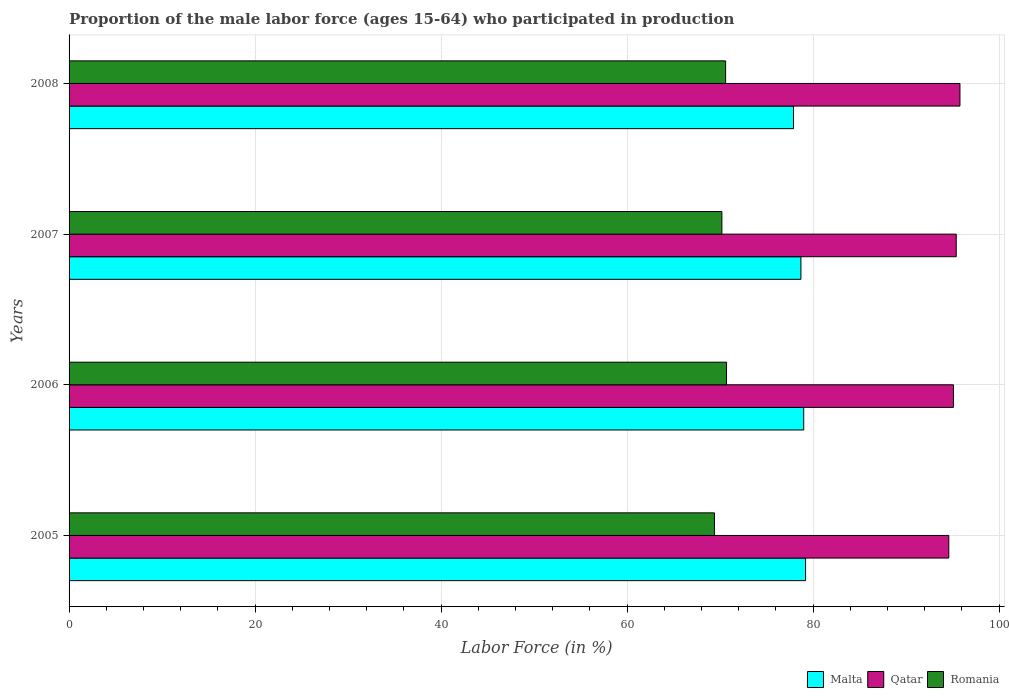How many different coloured bars are there?
Offer a very short reply. 3. What is the proportion of the male labor force who participated in production in Romania in 2006?
Your answer should be compact. 70.7. Across all years, what is the maximum proportion of the male labor force who participated in production in Romania?
Your response must be concise. 70.7. Across all years, what is the minimum proportion of the male labor force who participated in production in Malta?
Give a very brief answer. 77.9. What is the total proportion of the male labor force who participated in production in Malta in the graph?
Your response must be concise. 314.8. What is the difference between the proportion of the male labor force who participated in production in Qatar in 2005 and that in 2006?
Make the answer very short. -0.5. What is the difference between the proportion of the male labor force who participated in production in Malta in 2006 and the proportion of the male labor force who participated in production in Romania in 2005?
Your answer should be compact. 9.6. What is the average proportion of the male labor force who participated in production in Romania per year?
Give a very brief answer. 70.22. In the year 2008, what is the difference between the proportion of the male labor force who participated in production in Romania and proportion of the male labor force who participated in production in Malta?
Ensure brevity in your answer.  -7.3. In how many years, is the proportion of the male labor force who participated in production in Malta greater than 16 %?
Keep it short and to the point. 4. What is the ratio of the proportion of the male labor force who participated in production in Qatar in 2005 to that in 2006?
Give a very brief answer. 0.99. Is the proportion of the male labor force who participated in production in Qatar in 2006 less than that in 2007?
Offer a terse response. Yes. Is the difference between the proportion of the male labor force who participated in production in Romania in 2005 and 2007 greater than the difference between the proportion of the male labor force who participated in production in Malta in 2005 and 2007?
Ensure brevity in your answer.  No. What is the difference between the highest and the second highest proportion of the male labor force who participated in production in Qatar?
Provide a succinct answer. 0.4. What is the difference between the highest and the lowest proportion of the male labor force who participated in production in Qatar?
Offer a very short reply. 1.2. In how many years, is the proportion of the male labor force who participated in production in Romania greater than the average proportion of the male labor force who participated in production in Romania taken over all years?
Keep it short and to the point. 2. What does the 3rd bar from the top in 2005 represents?
Offer a terse response. Malta. What does the 2nd bar from the bottom in 2005 represents?
Give a very brief answer. Qatar. Is it the case that in every year, the sum of the proportion of the male labor force who participated in production in Romania and proportion of the male labor force who participated in production in Qatar is greater than the proportion of the male labor force who participated in production in Malta?
Your response must be concise. Yes. How many bars are there?
Give a very brief answer. 12. Does the graph contain any zero values?
Keep it short and to the point. No. Does the graph contain grids?
Offer a very short reply. Yes. How many legend labels are there?
Your answer should be compact. 3. How are the legend labels stacked?
Keep it short and to the point. Horizontal. What is the title of the graph?
Your answer should be compact. Proportion of the male labor force (ages 15-64) who participated in production. Does "New Caledonia" appear as one of the legend labels in the graph?
Offer a terse response. No. What is the label or title of the X-axis?
Ensure brevity in your answer.  Labor Force (in %). What is the Labor Force (in %) in Malta in 2005?
Make the answer very short. 79.2. What is the Labor Force (in %) of Qatar in 2005?
Provide a succinct answer. 94.6. What is the Labor Force (in %) of Romania in 2005?
Your answer should be very brief. 69.4. What is the Labor Force (in %) of Malta in 2006?
Your answer should be compact. 79. What is the Labor Force (in %) of Qatar in 2006?
Ensure brevity in your answer.  95.1. What is the Labor Force (in %) in Romania in 2006?
Your response must be concise. 70.7. What is the Labor Force (in %) in Malta in 2007?
Your response must be concise. 78.7. What is the Labor Force (in %) of Qatar in 2007?
Provide a succinct answer. 95.4. What is the Labor Force (in %) of Romania in 2007?
Offer a very short reply. 70.2. What is the Labor Force (in %) in Malta in 2008?
Give a very brief answer. 77.9. What is the Labor Force (in %) of Qatar in 2008?
Offer a very short reply. 95.8. What is the Labor Force (in %) of Romania in 2008?
Give a very brief answer. 70.6. Across all years, what is the maximum Labor Force (in %) in Malta?
Your answer should be very brief. 79.2. Across all years, what is the maximum Labor Force (in %) in Qatar?
Ensure brevity in your answer.  95.8. Across all years, what is the maximum Labor Force (in %) of Romania?
Your response must be concise. 70.7. Across all years, what is the minimum Labor Force (in %) of Malta?
Make the answer very short. 77.9. Across all years, what is the minimum Labor Force (in %) in Qatar?
Your answer should be compact. 94.6. Across all years, what is the minimum Labor Force (in %) in Romania?
Give a very brief answer. 69.4. What is the total Labor Force (in %) of Malta in the graph?
Provide a succinct answer. 314.8. What is the total Labor Force (in %) of Qatar in the graph?
Your answer should be very brief. 380.9. What is the total Labor Force (in %) of Romania in the graph?
Your answer should be very brief. 280.9. What is the difference between the Labor Force (in %) of Malta in 2005 and that in 2006?
Your response must be concise. 0.2. What is the difference between the Labor Force (in %) of Romania in 2005 and that in 2006?
Keep it short and to the point. -1.3. What is the difference between the Labor Force (in %) in Qatar in 2005 and that in 2007?
Your response must be concise. -0.8. What is the difference between the Labor Force (in %) of Qatar in 2005 and that in 2008?
Provide a succinct answer. -1.2. What is the difference between the Labor Force (in %) in Qatar in 2006 and that in 2007?
Your response must be concise. -0.3. What is the difference between the Labor Force (in %) in Malta in 2006 and that in 2008?
Provide a short and direct response. 1.1. What is the difference between the Labor Force (in %) of Romania in 2006 and that in 2008?
Your answer should be compact. 0.1. What is the difference between the Labor Force (in %) in Malta in 2007 and that in 2008?
Your answer should be very brief. 0.8. What is the difference between the Labor Force (in %) in Romania in 2007 and that in 2008?
Your answer should be very brief. -0.4. What is the difference between the Labor Force (in %) in Malta in 2005 and the Labor Force (in %) in Qatar in 2006?
Make the answer very short. -15.9. What is the difference between the Labor Force (in %) in Qatar in 2005 and the Labor Force (in %) in Romania in 2006?
Keep it short and to the point. 23.9. What is the difference between the Labor Force (in %) in Malta in 2005 and the Labor Force (in %) in Qatar in 2007?
Make the answer very short. -16.2. What is the difference between the Labor Force (in %) of Qatar in 2005 and the Labor Force (in %) of Romania in 2007?
Ensure brevity in your answer.  24.4. What is the difference between the Labor Force (in %) of Malta in 2005 and the Labor Force (in %) of Qatar in 2008?
Ensure brevity in your answer.  -16.6. What is the difference between the Labor Force (in %) of Malta in 2006 and the Labor Force (in %) of Qatar in 2007?
Offer a terse response. -16.4. What is the difference between the Labor Force (in %) of Malta in 2006 and the Labor Force (in %) of Romania in 2007?
Offer a very short reply. 8.8. What is the difference between the Labor Force (in %) in Qatar in 2006 and the Labor Force (in %) in Romania in 2007?
Your answer should be very brief. 24.9. What is the difference between the Labor Force (in %) of Malta in 2006 and the Labor Force (in %) of Qatar in 2008?
Give a very brief answer. -16.8. What is the difference between the Labor Force (in %) in Malta in 2006 and the Labor Force (in %) in Romania in 2008?
Make the answer very short. 8.4. What is the difference between the Labor Force (in %) of Malta in 2007 and the Labor Force (in %) of Qatar in 2008?
Give a very brief answer. -17.1. What is the difference between the Labor Force (in %) of Malta in 2007 and the Labor Force (in %) of Romania in 2008?
Ensure brevity in your answer.  8.1. What is the difference between the Labor Force (in %) in Qatar in 2007 and the Labor Force (in %) in Romania in 2008?
Your answer should be very brief. 24.8. What is the average Labor Force (in %) of Malta per year?
Provide a succinct answer. 78.7. What is the average Labor Force (in %) in Qatar per year?
Your answer should be compact. 95.22. What is the average Labor Force (in %) in Romania per year?
Make the answer very short. 70.22. In the year 2005, what is the difference between the Labor Force (in %) of Malta and Labor Force (in %) of Qatar?
Ensure brevity in your answer.  -15.4. In the year 2005, what is the difference between the Labor Force (in %) of Qatar and Labor Force (in %) of Romania?
Provide a succinct answer. 25.2. In the year 2006, what is the difference between the Labor Force (in %) in Malta and Labor Force (in %) in Qatar?
Your response must be concise. -16.1. In the year 2006, what is the difference between the Labor Force (in %) of Qatar and Labor Force (in %) of Romania?
Give a very brief answer. 24.4. In the year 2007, what is the difference between the Labor Force (in %) in Malta and Labor Force (in %) in Qatar?
Make the answer very short. -16.7. In the year 2007, what is the difference between the Labor Force (in %) in Malta and Labor Force (in %) in Romania?
Keep it short and to the point. 8.5. In the year 2007, what is the difference between the Labor Force (in %) of Qatar and Labor Force (in %) of Romania?
Provide a short and direct response. 25.2. In the year 2008, what is the difference between the Labor Force (in %) of Malta and Labor Force (in %) of Qatar?
Offer a terse response. -17.9. In the year 2008, what is the difference between the Labor Force (in %) of Malta and Labor Force (in %) of Romania?
Your response must be concise. 7.3. In the year 2008, what is the difference between the Labor Force (in %) of Qatar and Labor Force (in %) of Romania?
Your response must be concise. 25.2. What is the ratio of the Labor Force (in %) in Romania in 2005 to that in 2006?
Provide a short and direct response. 0.98. What is the ratio of the Labor Force (in %) of Malta in 2005 to that in 2007?
Offer a terse response. 1.01. What is the ratio of the Labor Force (in %) of Qatar in 2005 to that in 2007?
Your response must be concise. 0.99. What is the ratio of the Labor Force (in %) of Malta in 2005 to that in 2008?
Offer a very short reply. 1.02. What is the ratio of the Labor Force (in %) of Qatar in 2005 to that in 2008?
Your response must be concise. 0.99. What is the ratio of the Labor Force (in %) in Malta in 2006 to that in 2007?
Your answer should be very brief. 1. What is the ratio of the Labor Force (in %) in Qatar in 2006 to that in 2007?
Offer a very short reply. 1. What is the ratio of the Labor Force (in %) of Romania in 2006 to that in 2007?
Your response must be concise. 1.01. What is the ratio of the Labor Force (in %) in Malta in 2006 to that in 2008?
Provide a short and direct response. 1.01. What is the ratio of the Labor Force (in %) of Romania in 2006 to that in 2008?
Provide a short and direct response. 1. What is the ratio of the Labor Force (in %) of Malta in 2007 to that in 2008?
Your answer should be very brief. 1.01. What is the ratio of the Labor Force (in %) of Qatar in 2007 to that in 2008?
Keep it short and to the point. 1. What is the ratio of the Labor Force (in %) of Romania in 2007 to that in 2008?
Your response must be concise. 0.99. What is the difference between the highest and the second highest Labor Force (in %) in Malta?
Your answer should be compact. 0.2. What is the difference between the highest and the second highest Labor Force (in %) in Qatar?
Your answer should be compact. 0.4. What is the difference between the highest and the lowest Labor Force (in %) in Romania?
Give a very brief answer. 1.3. 